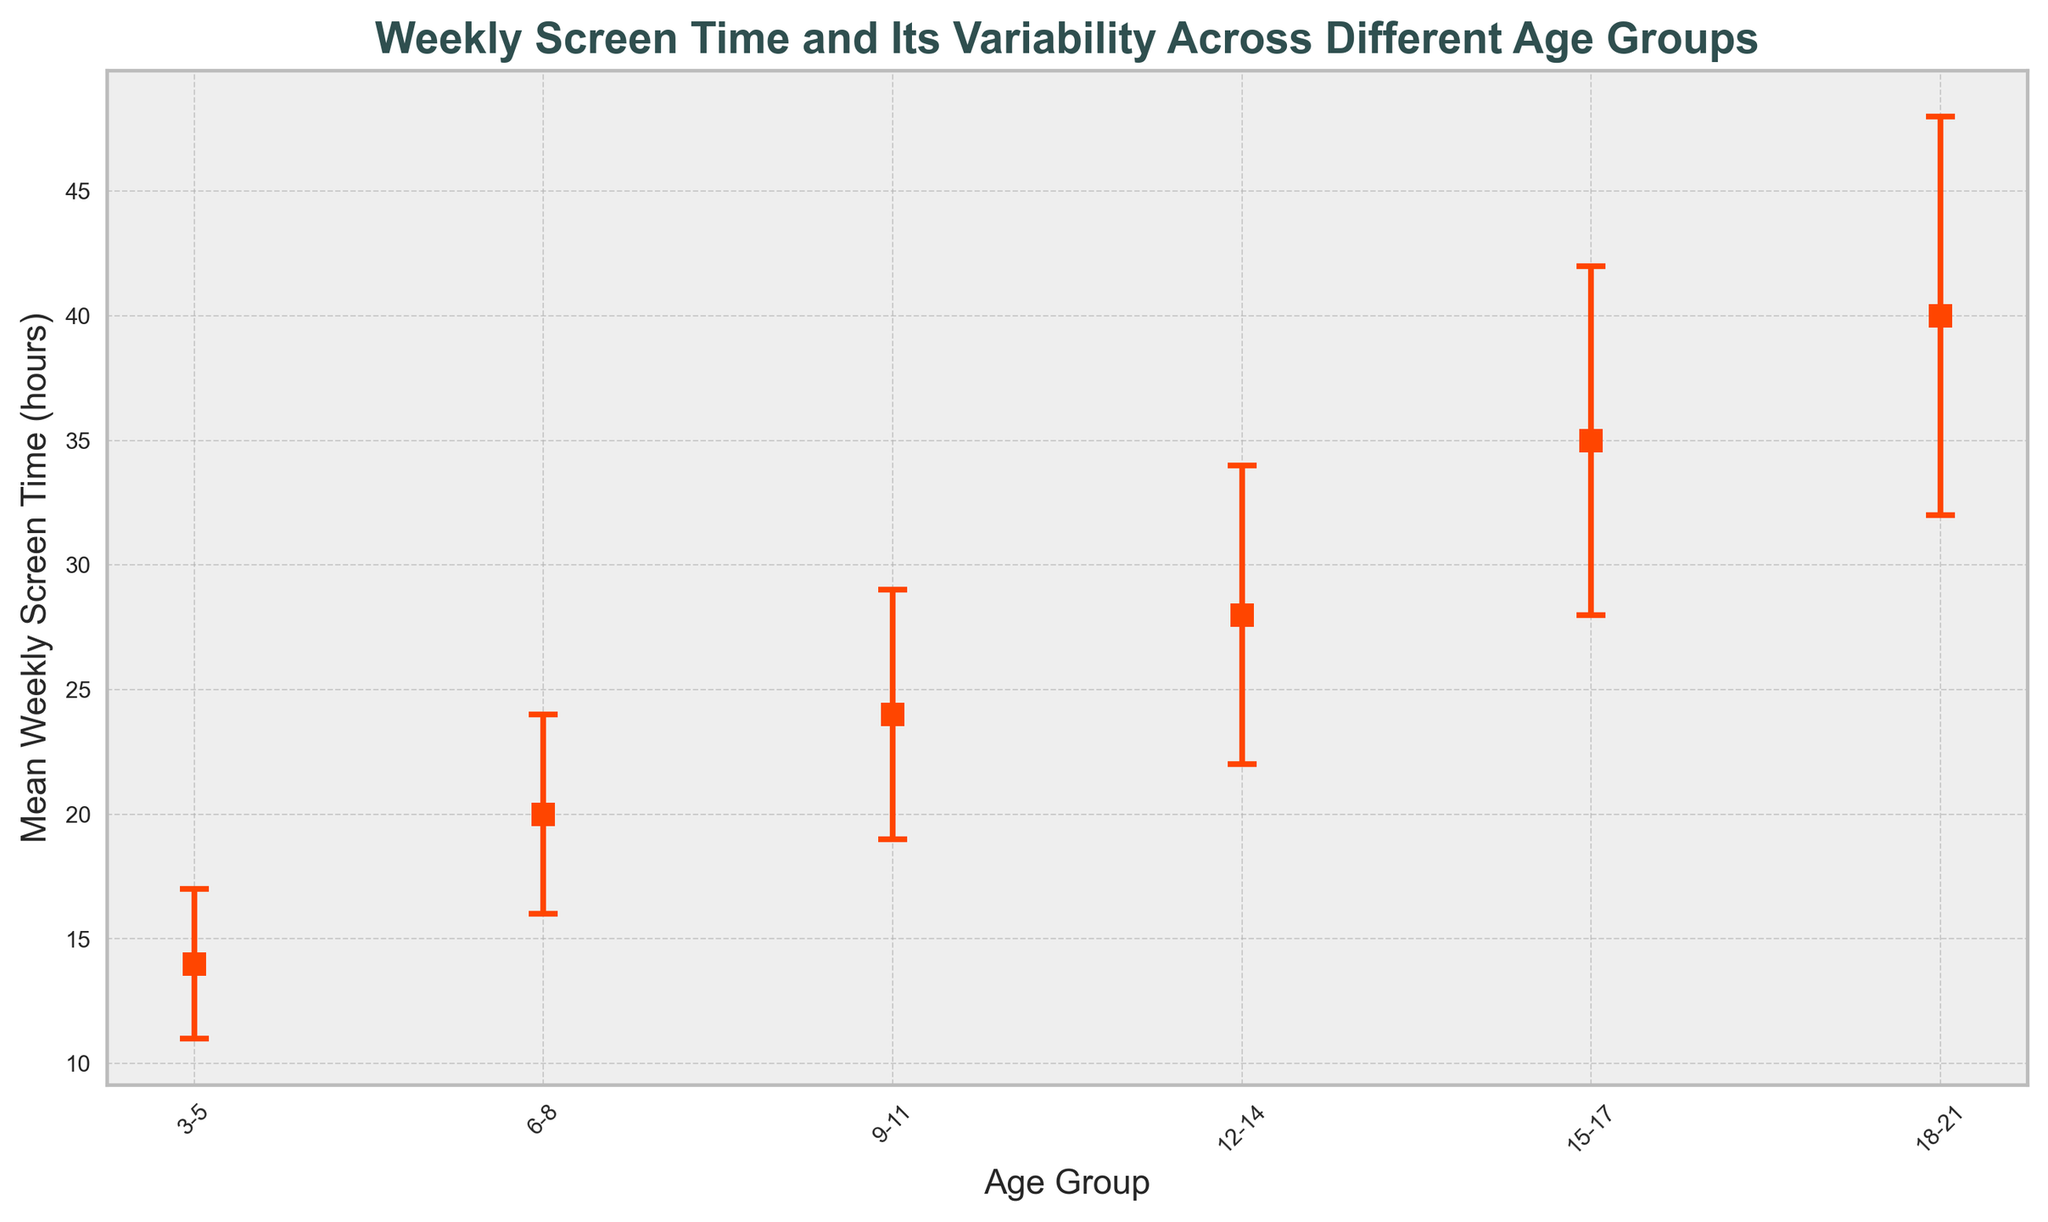What is the mean weekly screen time for the 9-11 age group? The figure shows the mean weekly screen time as 24 hours for the 9-11 age group.
Answer: 24 hours Which age group has the highest mean weekly screen time? By examining the figure, the age group 18-21 has the highest mean weekly screen time at 40 hours.
Answer: 18-21 Compare the mean weekly screen time between the 6-8 and 12-14 age groups. Which is higher and by how much? The mean weekly screen time for the 6-8 age group is 20 hours, and for the 12-14 age group, it is 28 hours. The difference is 28 - 20 = 8 hours.
Answer: 12-14 by 8 hours How does the variability (standard deviation) in screen time change as the age group increases? The standard deviation increases with age: 3 hours for 3-5, 4 for 6-8, 5 for 9-11, 6 for 12-14, 7 for 15-17, and 8 for 18-21, indicating more variability as age increases.
Answer: Increases What is the range of the mean weekly screen time across all age groups? The lowest mean weekly screen time is 14 hours for the 3-5 age group, and the highest is 40 hours for the 18-21 age group, so the range is 40 - 14 = 26 hours.
Answer: 26 hours Which age group has the smallest variability in their screen time? The smallest standard deviation is 3 hours for the 3-5 age group.
Answer: 3-5 Determine the combined mean weekly screen time for the 3-5 and 6-8 age groups. The mean weekly screen time for the 3-5 age group is 14 hours and 20 hours for the 6-8 age group. The combined mean is 14 + 20 = 34 hours.
Answer: 34 hours Which age group sees the largest increase in mean weekly screen time compared to its previous age group? The increases are: 6 hours (6-8 to 3-5), 4 hours (9-11 to 6-8), 4 hours (12-14 to 9-11), 7 hours (15-17 to 12-14), 5 hours (18-21 to 15-17). The largest increase is from 3-5 to 6-8 with 6 hours.
Answer: 6-8 For the 15-17 age group, calculate the upper limit of weekly screen time considering the variability. The mean weekly screen time is 35 hours with a standard deviation of 7 hours. The upper limit is 35 + 7 = 42 hours.
Answer: 42 hours Among all age groups, which has the most consistent (least variable) screen time pattern? The 3-5 age group has the smallest standard deviation of 3, indicating it is the most consistent in screen time pattern.
Answer: 3-5 